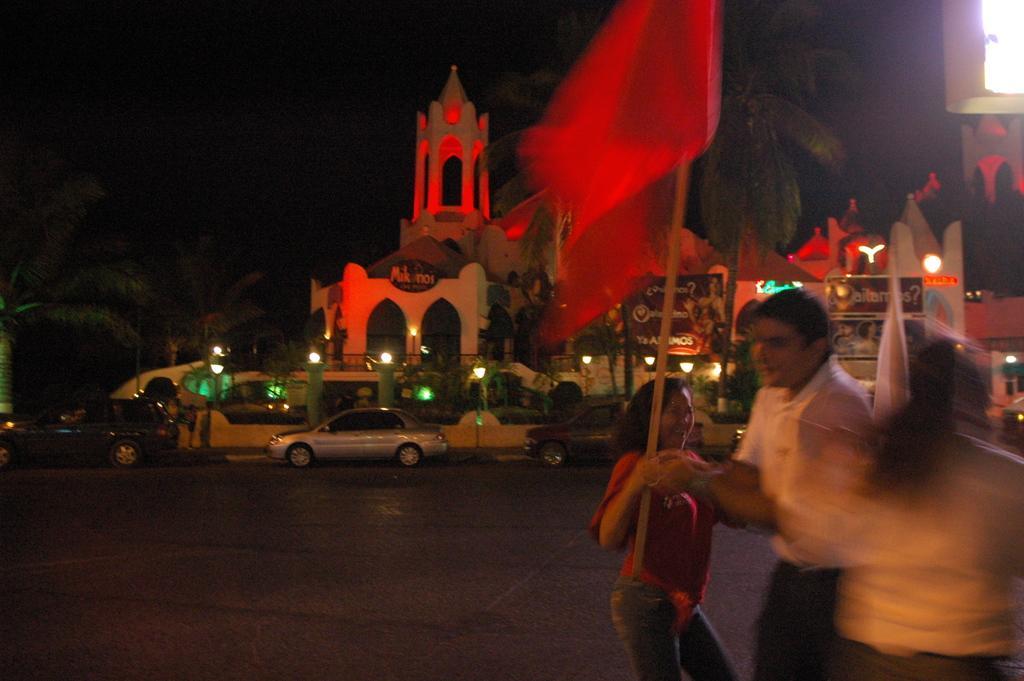Describe this image in one or two sentences. In this picture there is a man who is wearing white shirt and black trouser. Beside him there is a woman who is wearing red t-shirt and jeans. She is reading a flag. In the back we can see many cars on the road. Beside that we can see the street lights. In the background we can see the monument and trees. At the top we can see the darkness. In the top right corner there is a light. 